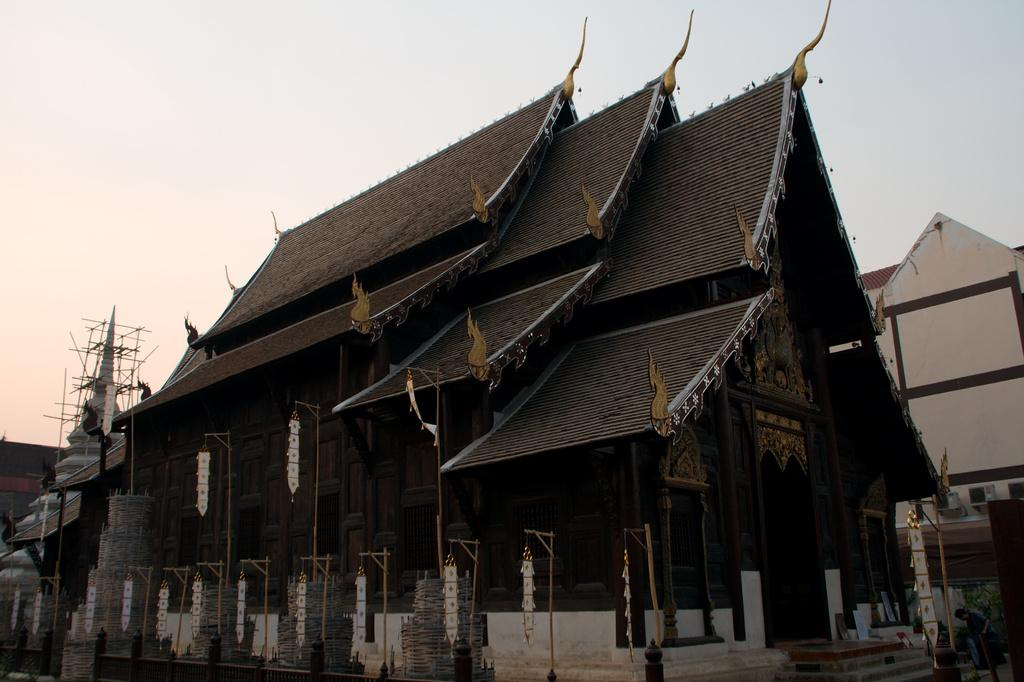What are the colors of the two buildings in the image? There is a brown-colored building and a cream-colored building in the image. Can you describe the sky in the image? The sky is white in the image. What type of bushes can be seen growing in the sand in the image? There are no bushes or sand present in the image; it features two buildings and a white sky. 